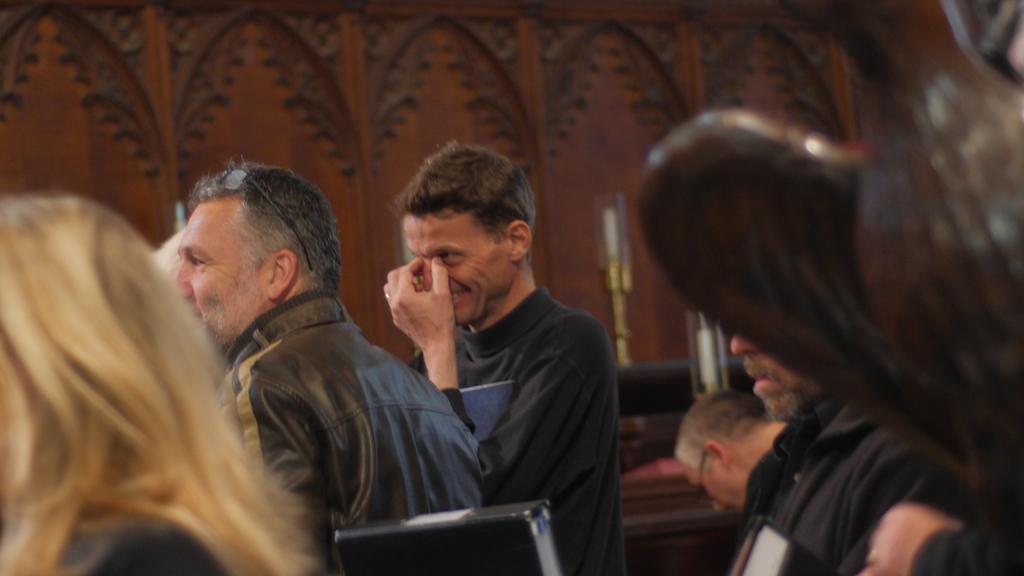In one or two sentences, can you explain what this image depicts? In this image we can able to see some persons, and there is a person who is having glasses on his head, we can able to see two candles here. 